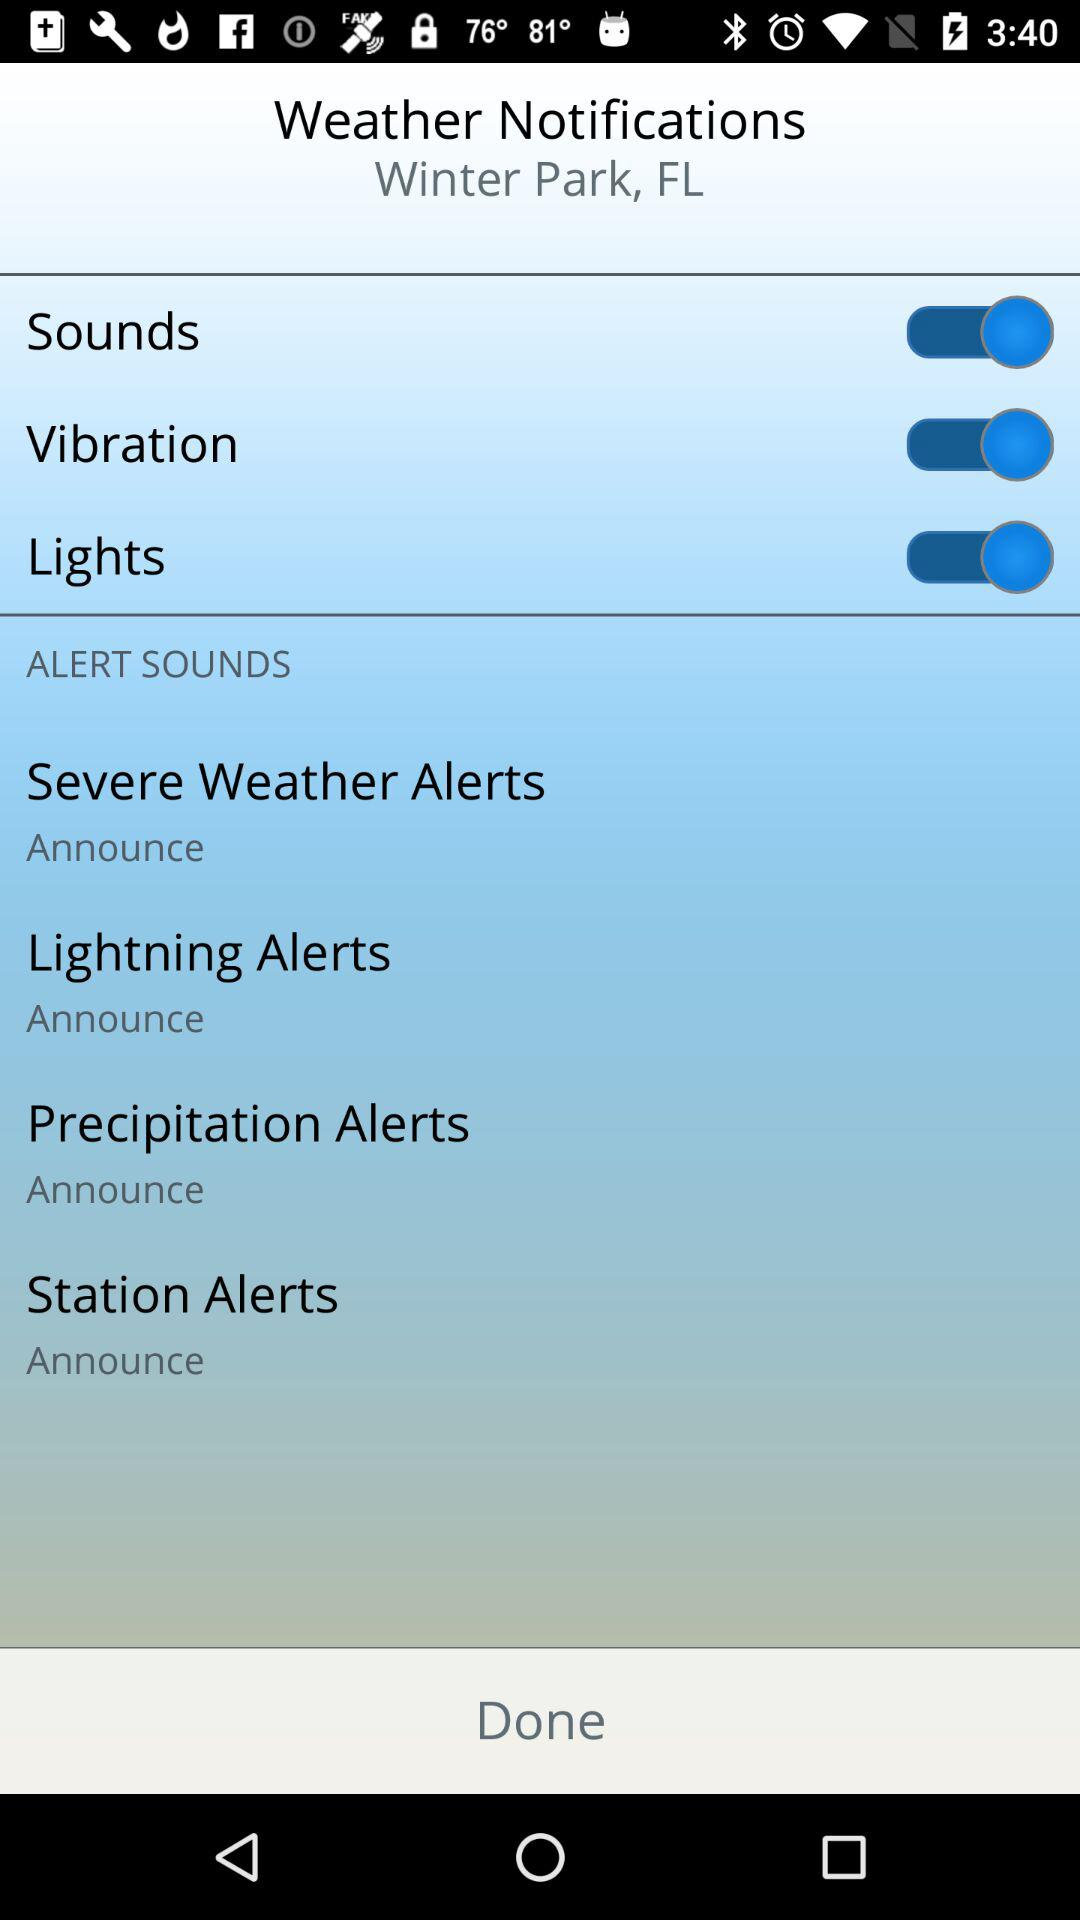What is the location for "Weather Notifications"? The location is Winter Park, FL. 